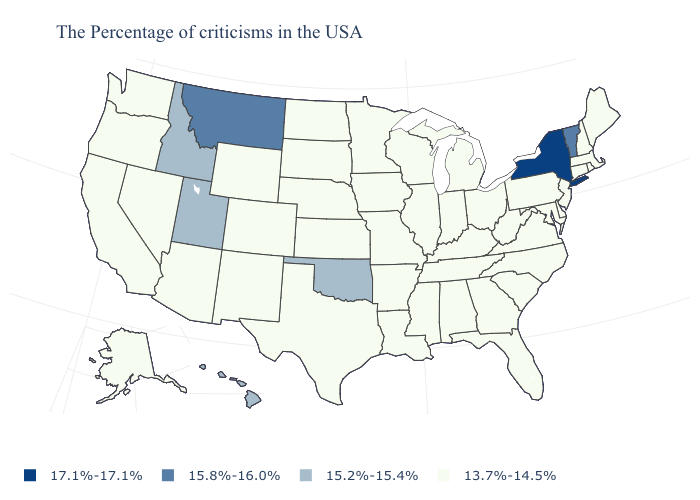Does Massachusetts have the lowest value in the USA?
Answer briefly. Yes. What is the highest value in states that border Oregon?
Answer briefly. 15.2%-15.4%. Which states have the lowest value in the West?
Be succinct. Wyoming, Colorado, New Mexico, Arizona, Nevada, California, Washington, Oregon, Alaska. What is the highest value in the USA?
Give a very brief answer. 17.1%-17.1%. What is the value of Georgia?
Be succinct. 13.7%-14.5%. What is the highest value in the West ?
Short answer required. 15.8%-16.0%. What is the value of Wisconsin?
Be succinct. 13.7%-14.5%. Which states have the lowest value in the USA?
Answer briefly. Maine, Massachusetts, Rhode Island, New Hampshire, Connecticut, New Jersey, Delaware, Maryland, Pennsylvania, Virginia, North Carolina, South Carolina, West Virginia, Ohio, Florida, Georgia, Michigan, Kentucky, Indiana, Alabama, Tennessee, Wisconsin, Illinois, Mississippi, Louisiana, Missouri, Arkansas, Minnesota, Iowa, Kansas, Nebraska, Texas, South Dakota, North Dakota, Wyoming, Colorado, New Mexico, Arizona, Nevada, California, Washington, Oregon, Alaska. Does Louisiana have a lower value than North Dakota?
Write a very short answer. No. Name the states that have a value in the range 13.7%-14.5%?
Give a very brief answer. Maine, Massachusetts, Rhode Island, New Hampshire, Connecticut, New Jersey, Delaware, Maryland, Pennsylvania, Virginia, North Carolina, South Carolina, West Virginia, Ohio, Florida, Georgia, Michigan, Kentucky, Indiana, Alabama, Tennessee, Wisconsin, Illinois, Mississippi, Louisiana, Missouri, Arkansas, Minnesota, Iowa, Kansas, Nebraska, Texas, South Dakota, North Dakota, Wyoming, Colorado, New Mexico, Arizona, Nevada, California, Washington, Oregon, Alaska. What is the value of Colorado?
Be succinct. 13.7%-14.5%. What is the value of Alabama?
Be succinct. 13.7%-14.5%. What is the lowest value in the South?
Concise answer only. 13.7%-14.5%. What is the lowest value in the MidWest?
Concise answer only. 13.7%-14.5%. Name the states that have a value in the range 13.7%-14.5%?
Quick response, please. Maine, Massachusetts, Rhode Island, New Hampshire, Connecticut, New Jersey, Delaware, Maryland, Pennsylvania, Virginia, North Carolina, South Carolina, West Virginia, Ohio, Florida, Georgia, Michigan, Kentucky, Indiana, Alabama, Tennessee, Wisconsin, Illinois, Mississippi, Louisiana, Missouri, Arkansas, Minnesota, Iowa, Kansas, Nebraska, Texas, South Dakota, North Dakota, Wyoming, Colorado, New Mexico, Arizona, Nevada, California, Washington, Oregon, Alaska. 